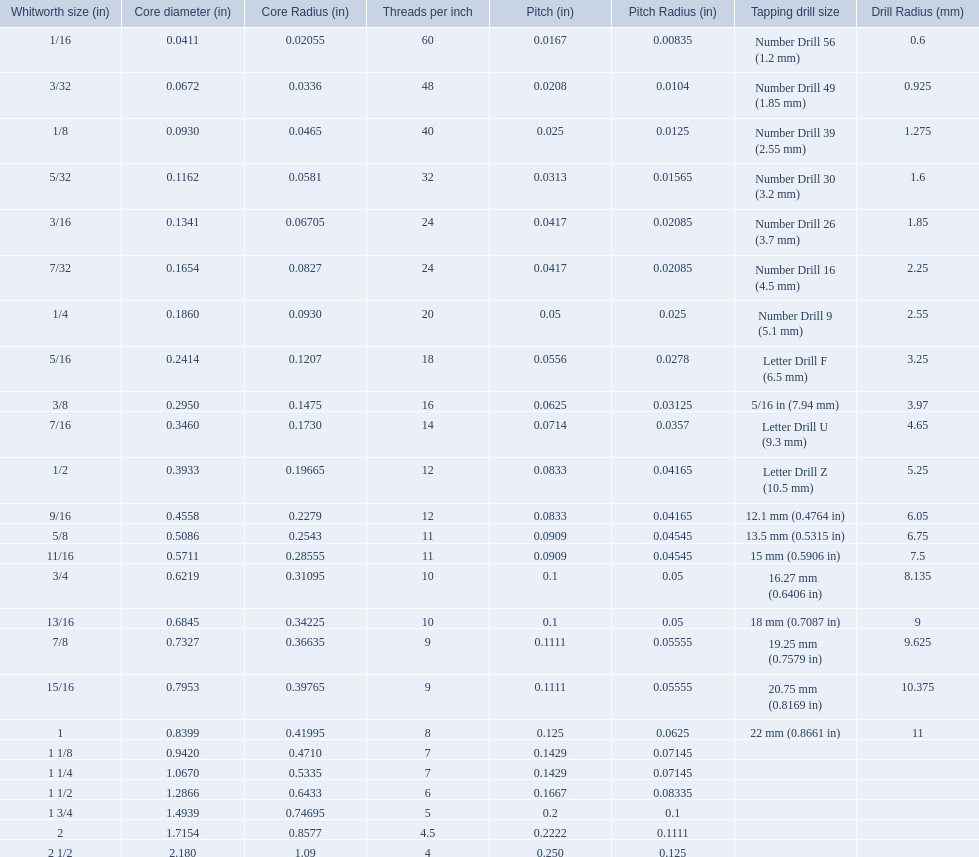What is the core diameter for the number drill 26? 0.1341. Help me parse the entirety of this table. {'header': ['Whitworth size (in)', 'Core diameter (in)', 'Core Radius (in)', 'Threads per\xa0inch', 'Pitch (in)', 'Pitch Radius (in)', 'Tapping drill size', 'Drill Radius (mm)'], 'rows': [['1/16', '0.0411', '0.02055', '60', '0.0167', '0.00835', 'Number Drill 56 (1.2\xa0mm)', '0.6'], ['3/32', '0.0672', '0.0336', '48', '0.0208', '0.0104', 'Number Drill 49 (1.85\xa0mm)', '0.925'], ['1/8', '0.0930', '0.0465', '40', '0.025', '0.0125', 'Number Drill 39 (2.55\xa0mm)', '1.275'], ['5/32', '0.1162', '0.0581', '32', '0.0313', '0.01565', 'Number Drill 30 (3.2\xa0mm)', '1.6'], ['3/16', '0.1341', '0.06705', '24', '0.0417', '0.02085', 'Number Drill 26 (3.7\xa0mm)', '1.85'], ['7/32', '0.1654', '0.0827', '24', '0.0417', '0.02085', 'Number Drill 16 (4.5\xa0mm)', '2.25'], ['1/4', '0.1860', '0.0930', '20', '0.05', '0.025', 'Number Drill 9 (5.1\xa0mm)', '2.55'], ['5/16', '0.2414', '0.1207', '18', '0.0556', '0.0278', 'Letter Drill F (6.5\xa0mm)', '3.25'], ['3/8', '0.2950', '0.1475', '16', '0.0625', '0.03125', '5/16\xa0in (7.94\xa0mm)', '3.97'], ['7/16', '0.3460', '0.1730', '14', '0.0714', '0.0357', 'Letter Drill U (9.3\xa0mm)', '4.65'], ['1/2', '0.3933', '0.19665', '12', '0.0833', '0.04165', 'Letter Drill Z (10.5\xa0mm)', '5.25'], ['9/16', '0.4558', '0.2279', '12', '0.0833', '0.04165', '12.1\xa0mm (0.4764\xa0in)', '6.05'], ['5/8', '0.5086', '0.2543', '11', '0.0909', '0.04545', '13.5\xa0mm (0.5315\xa0in)', '6.75'], ['11/16', '0.5711', '0.28555', '11', '0.0909', '0.04545', '15\xa0mm (0.5906\xa0in)', '7.5'], ['3/4', '0.6219', '0.31095', '10', '0.1', '0.05', '16.27\xa0mm (0.6406\xa0in)', '8.135'], ['13/16', '0.6845', '0.34225', '10', '0.1', '0.05', '18\xa0mm (0.7087\xa0in)', '9'], ['7/8', '0.7327', '0.36635', '9', '0.1111', '0.05555', '19.25\xa0mm (0.7579\xa0in)', '9.625'], ['15/16', '0.7953', '0.39765', '9', '0.1111', '0.05555', '20.75\xa0mm (0.8169\xa0in)', '10.375'], ['1', '0.8399', '0.41995', '8', '0.125', '0.0625', '22\xa0mm (0.8661\xa0in)', '11'], ['1 1/8', '0.9420', '0.4710', '7', '0.1429', '0.07145', '', ''], ['1 1/4', '1.0670', '0.5335', '7', '0.1429', '0.07145', '', ''], ['1 1/2', '1.2866', '0.6433', '6', '0.1667', '0.08335', '', ''], ['1 3/4', '1.4939', '0.74695', '5', '0.2', '0.1', '', ''], ['2', '1.7154', '0.8577', '4.5', '0.2222', '0.1111', '', ''], ['2 1/2', '2.180', '1.09', '4', '0.250', '0.125', '', '']]} What is the whitworth size (in) for this core diameter? 3/16. 